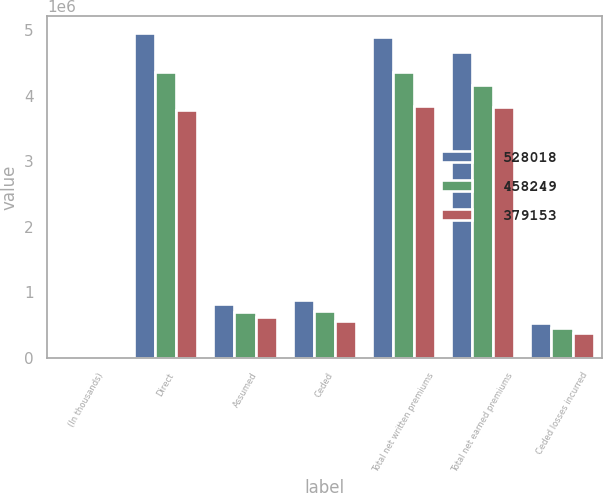Convert chart to OTSL. <chart><loc_0><loc_0><loc_500><loc_500><stacked_bar_chart><ecel><fcel>(In thousands)<fcel>Direct<fcel>Assumed<fcel>Ceded<fcel>Total net written premiums<fcel>Total net earned premiums<fcel>Ceded losses incurred<nl><fcel>528018<fcel>2012<fcel>4.96407e+06<fcel>815810<fcel>881340<fcel>4.89854e+06<fcel>4.67352e+06<fcel>528018<nl><fcel>458249<fcel>2011<fcel>4.37009e+06<fcel>707221<fcel>719945<fcel>4.35737e+06<fcel>4.16087e+06<fcel>458249<nl><fcel>379153<fcel>2010<fcel>3.78825e+06<fcel>627826<fcel>565151<fcel>3.85093e+06<fcel>3.83558e+06<fcel>379153<nl></chart> 